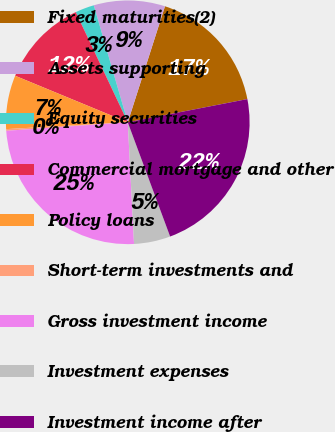Convert chart. <chart><loc_0><loc_0><loc_500><loc_500><pie_chart><fcel>Fixed maturities(2)<fcel>Assets supporting<fcel>Equity securities<fcel>Commercial mortgage and other<fcel>Policy loans<fcel>Short-term investments and<fcel>Gross investment income<fcel>Investment expenses<fcel>Investment income after<nl><fcel>17.01%<fcel>9.44%<fcel>2.52%<fcel>11.74%<fcel>7.13%<fcel>0.22%<fcel>24.71%<fcel>4.83%<fcel>22.4%<nl></chart> 